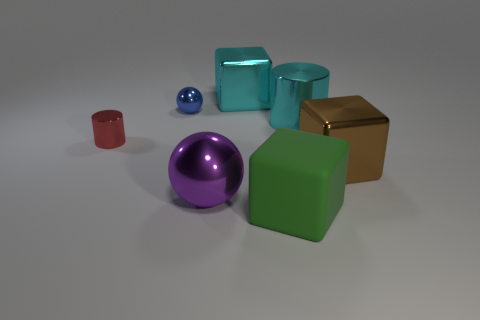How many big shiny objects are the same color as the big metallic cylinder?
Your answer should be very brief. 1. What material is the thing that is the same color as the large cylinder?
Your answer should be very brief. Metal. Is the cylinder that is left of the large purple metal thing made of the same material as the blue thing?
Provide a short and direct response. Yes. The large purple object to the left of the big brown block has what shape?
Provide a succinct answer. Sphere. What material is the brown thing that is the same size as the purple metallic thing?
Give a very brief answer. Metal. How many things are metallic objects in front of the red cylinder or objects that are to the left of the big metallic cylinder?
Offer a terse response. 6. What size is the cyan cylinder that is the same material as the tiny blue thing?
Ensure brevity in your answer.  Large. What number of rubber objects are big purple cylinders or blue things?
Offer a terse response. 0. What is the size of the cyan metal block?
Your answer should be compact. Large. Is the brown metallic thing the same size as the green object?
Your answer should be compact. Yes. 